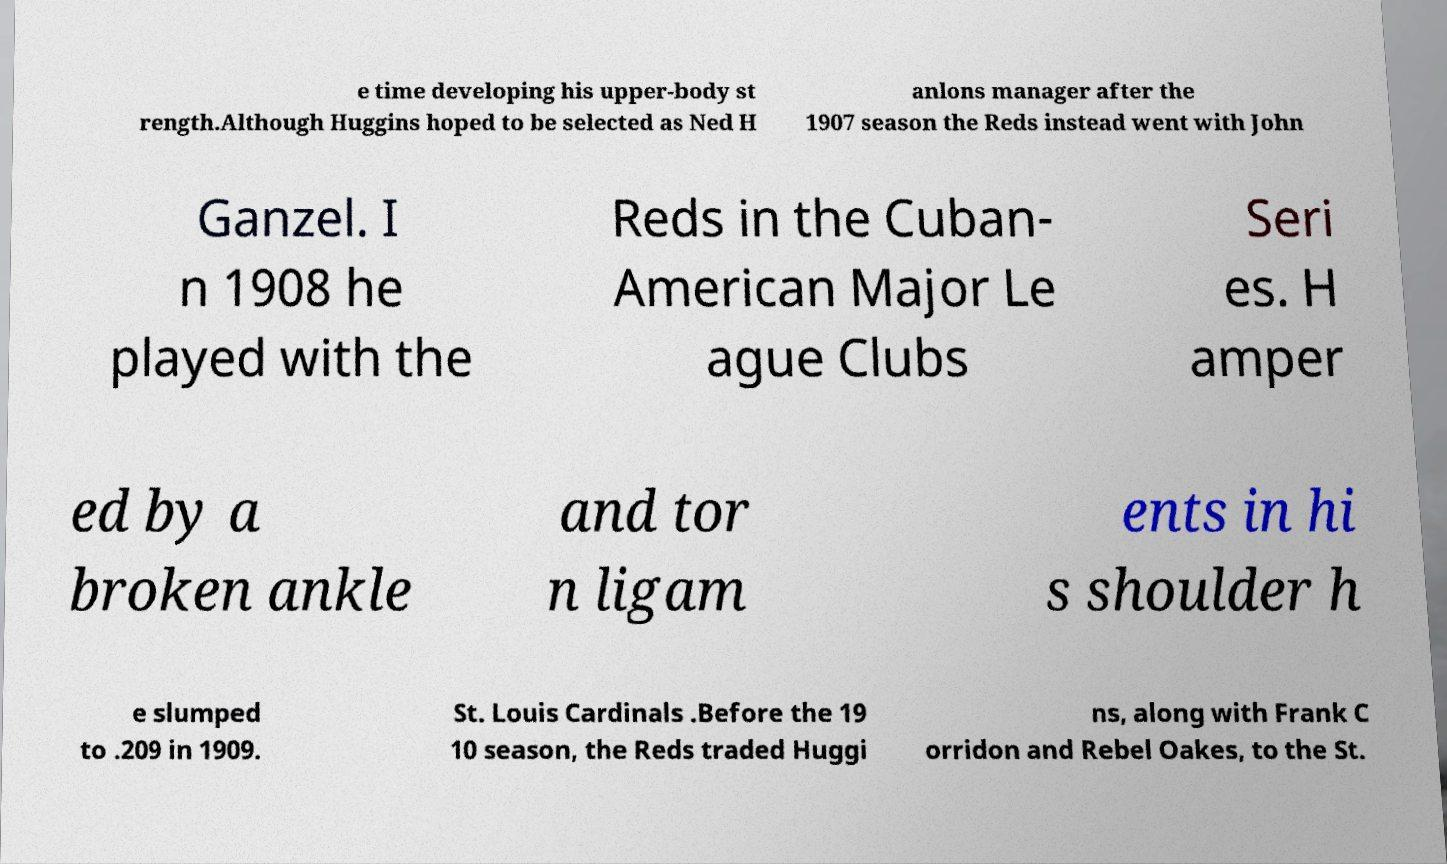There's text embedded in this image that I need extracted. Can you transcribe it verbatim? e time developing his upper-body st rength.Although Huggins hoped to be selected as Ned H anlons manager after the 1907 season the Reds instead went with John Ganzel. I n 1908 he played with the Reds in the Cuban- American Major Le ague Clubs Seri es. H amper ed by a broken ankle and tor n ligam ents in hi s shoulder h e slumped to .209 in 1909. St. Louis Cardinals .Before the 19 10 season, the Reds traded Huggi ns, along with Frank C orridon and Rebel Oakes, to the St. 